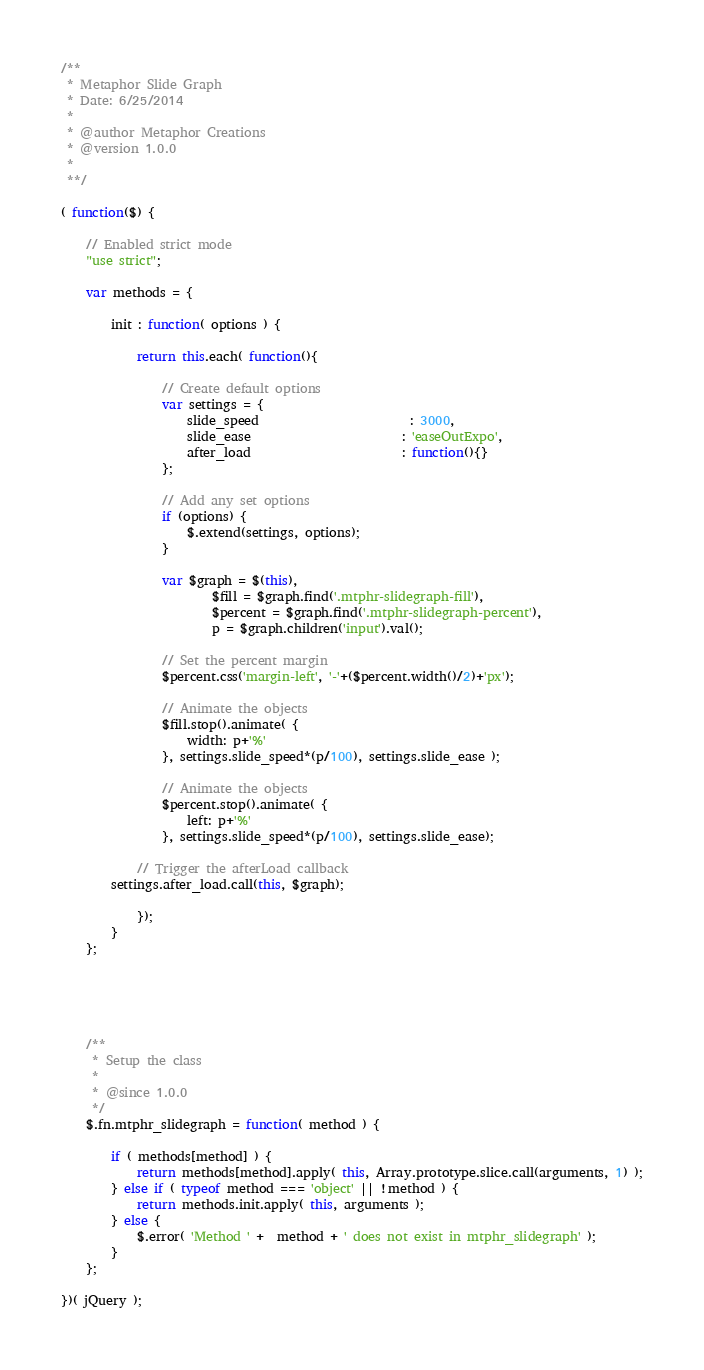Convert code to text. <code><loc_0><loc_0><loc_500><loc_500><_JavaScript_>/**
 * Metaphor Slide Graph
 * Date: 6/25/2014
 *
 * @author Metaphor Creations
 * @version 1.0.0
 *
 **/

( function($) {

	// Enabled strict mode
	"use strict";

	var methods = {

		init : function( options ) {

			return this.each( function(){

				// Create default options
				var settings = {
					slide_speed						: 3000,
					slide_ease						: 'easeOutExpo',
					after_load						: function(){}
				};

				// Add any set options
				if (options) {
					$.extend(settings, options);
				}

				var $graph = $(this),
						$fill = $graph.find('.mtphr-slidegraph-fill'),
						$percent = $graph.find('.mtphr-slidegraph-percent'),
						p = $graph.children('input').val();
						
				// Set the percent margin
				$percent.css('margin-left', '-'+($percent.width()/2)+'px');

				// Animate the objects
				$fill.stop().animate( {
					width: p+'%'
				}, settings.slide_speed*(p/100), settings.slide_ease );

				// Animate the objects
				$percent.stop().animate( {
					left: p+'%'
				}, settings.slide_speed*(p/100), settings.slide_ease);

		    // Trigger the afterLoad callback
        settings.after_load.call(this, $graph);

			});
		}
	};





	/**
	 * Setup the class
	 *
	 * @since 1.0.0
	 */
	$.fn.mtphr_slidegraph = function( method ) {

		if ( methods[method] ) {
			return methods[method].apply( this, Array.prototype.slice.call(arguments, 1) );
		} else if ( typeof method === 'object' || !method ) {
			return methods.init.apply( this, arguments );
		} else {
			$.error( 'Method ' +  method + ' does not exist in mtphr_slidegraph' );
		}
	};

})( jQuery );</code> 